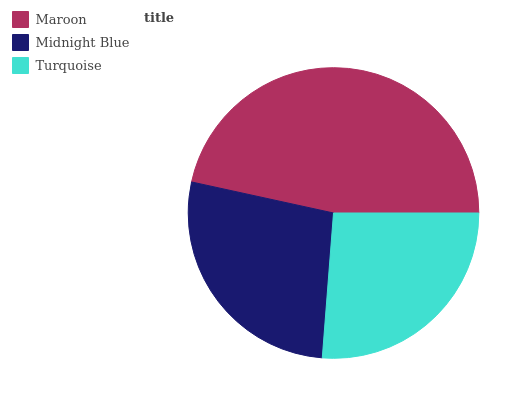Is Turquoise the minimum?
Answer yes or no. Yes. Is Maroon the maximum?
Answer yes or no. Yes. Is Midnight Blue the minimum?
Answer yes or no. No. Is Midnight Blue the maximum?
Answer yes or no. No. Is Maroon greater than Midnight Blue?
Answer yes or no. Yes. Is Midnight Blue less than Maroon?
Answer yes or no. Yes. Is Midnight Blue greater than Maroon?
Answer yes or no. No. Is Maroon less than Midnight Blue?
Answer yes or no. No. Is Midnight Blue the high median?
Answer yes or no. Yes. Is Midnight Blue the low median?
Answer yes or no. Yes. Is Maroon the high median?
Answer yes or no. No. Is Turquoise the low median?
Answer yes or no. No. 